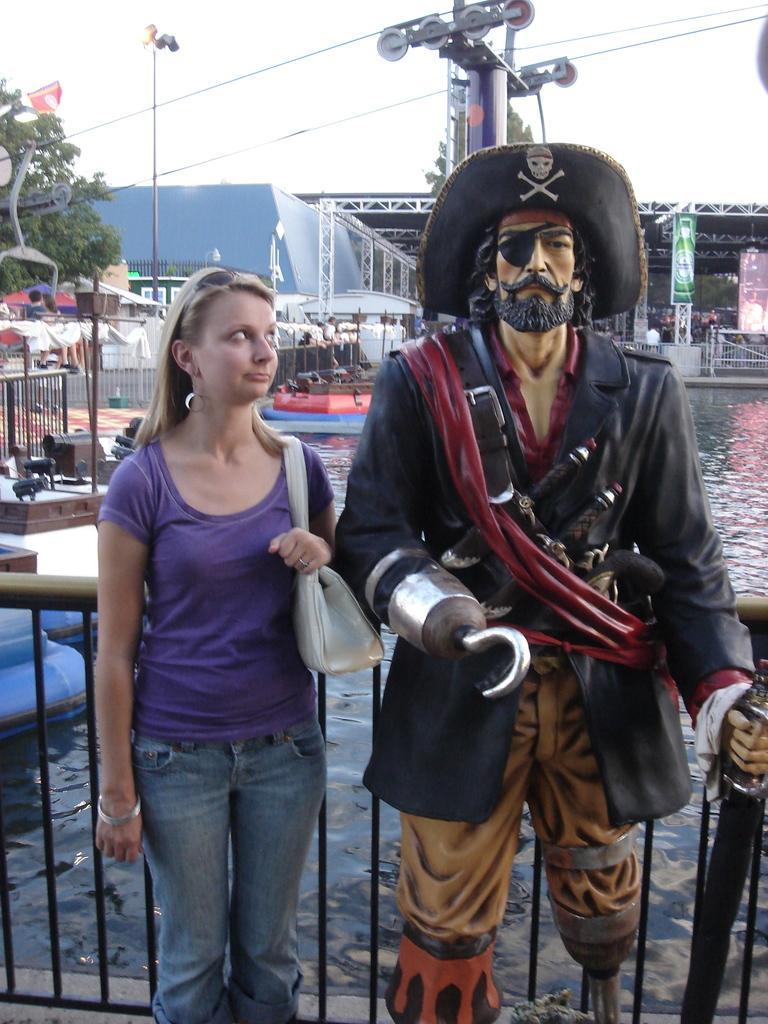How would you summarize this image in a sentence or two? In this image I can see on the right side there is a doll in the shape of a man, beside it a woman is standing, she is wearing t-shirt, trouser. At the back side there are boats in the water, on the left side there are trees, at the top it is the sky. 